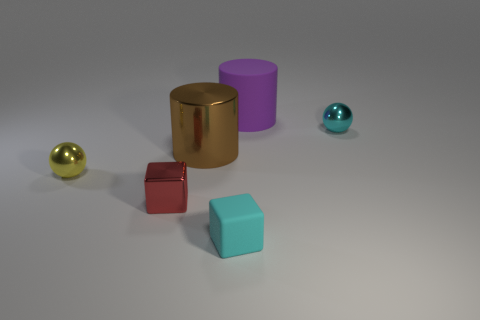The brown metallic object has what shape?
Keep it short and to the point. Cylinder. There is a tiny cyan object behind the large metal object; is there a thing that is on the left side of it?
Give a very brief answer. Yes. There is another cube that is the same size as the metallic block; what is it made of?
Your response must be concise. Rubber. Is there a rubber object of the same size as the yellow shiny ball?
Your answer should be compact. Yes. There is a large purple object right of the yellow sphere; what is its material?
Provide a short and direct response. Rubber. Is the ball to the left of the small rubber cube made of the same material as the big purple object?
Offer a very short reply. No. What is the shape of the yellow metallic object that is the same size as the cyan matte object?
Provide a succinct answer. Sphere. What number of small metal spheres have the same color as the tiny rubber block?
Provide a short and direct response. 1. Is the number of cyan cubes that are on the left side of the yellow thing less than the number of cyan spheres that are left of the cyan block?
Ensure brevity in your answer.  No. Are there any cyan rubber things on the left side of the yellow shiny object?
Ensure brevity in your answer.  No. 